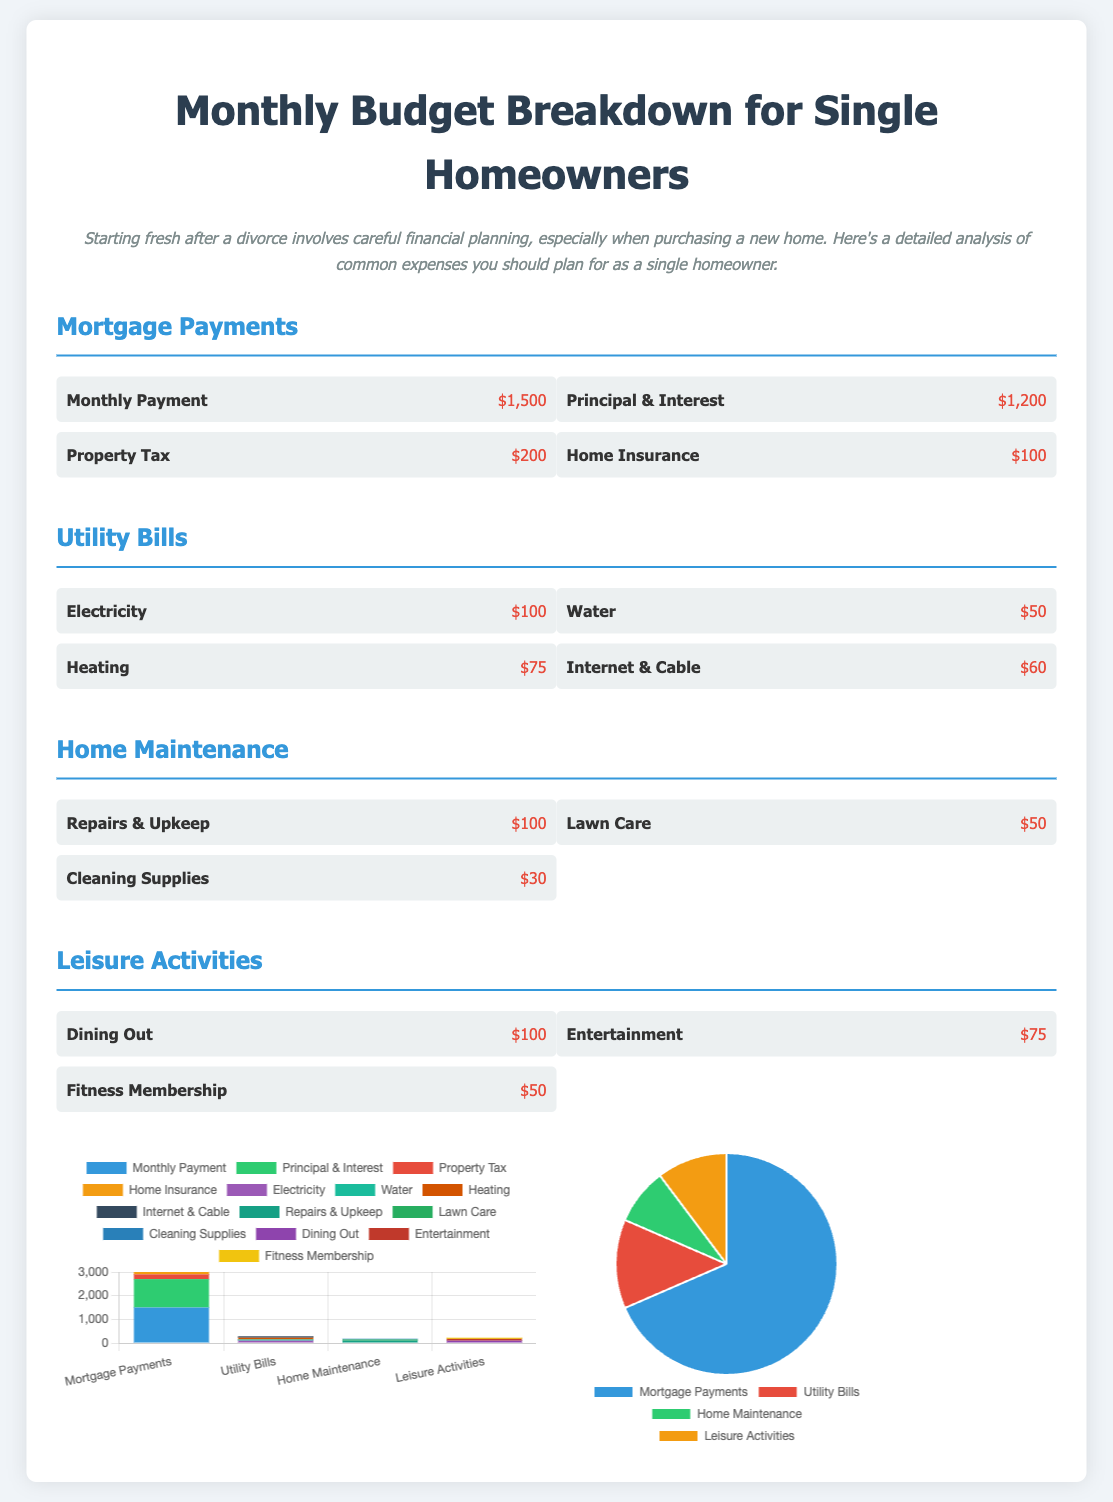What is the total monthly mortgage payment? The total monthly mortgage payment includes principal & interest, property tax, and home insurance, which sums up to $1200 + $200 + $100 = $1500.
Answer: $1500 How much is spent on utility bills? The total amount spent on utility bills is the sum of all utility costs: $100 + $50 + $75 + $60 = $285.
Answer: $285 What is the cost of dining out? The cost of dining out is specifically listed in the leisure activities section of the document.
Answer: $100 How much is allocated for home maintenance repairs and upkeep? The home maintenance section specifies that repairs and upkeep cost $100.
Answer: $100 What percentage of the total budget is spent on mortgage payments? The pie chart shows that mortgage payments represent $1500 out of a total of $2185, thus approximately 68.69 percent of the budget.
Answer: 68.69 percent What are the three main components of mortgage payments? The mortgage payments consist of principal & interest, property tax, and home insurance.
Answer: Principal & Interest, Property Tax, Home Insurance In which category do cleaning supplies fall? Cleaning supplies are listed under the home maintenance section of the document.
Answer: Home Maintenance How much is spent on entertainment activities? Entertainment includes a cost of $75 as part of leisure activities.
Answer: $75 What is the total budget for leisure activities? The total budget for leisure activities is calculated by summing dining out, entertainment, and fitness membership costs: $100 + $75 + $50 = $225.
Answer: $225 